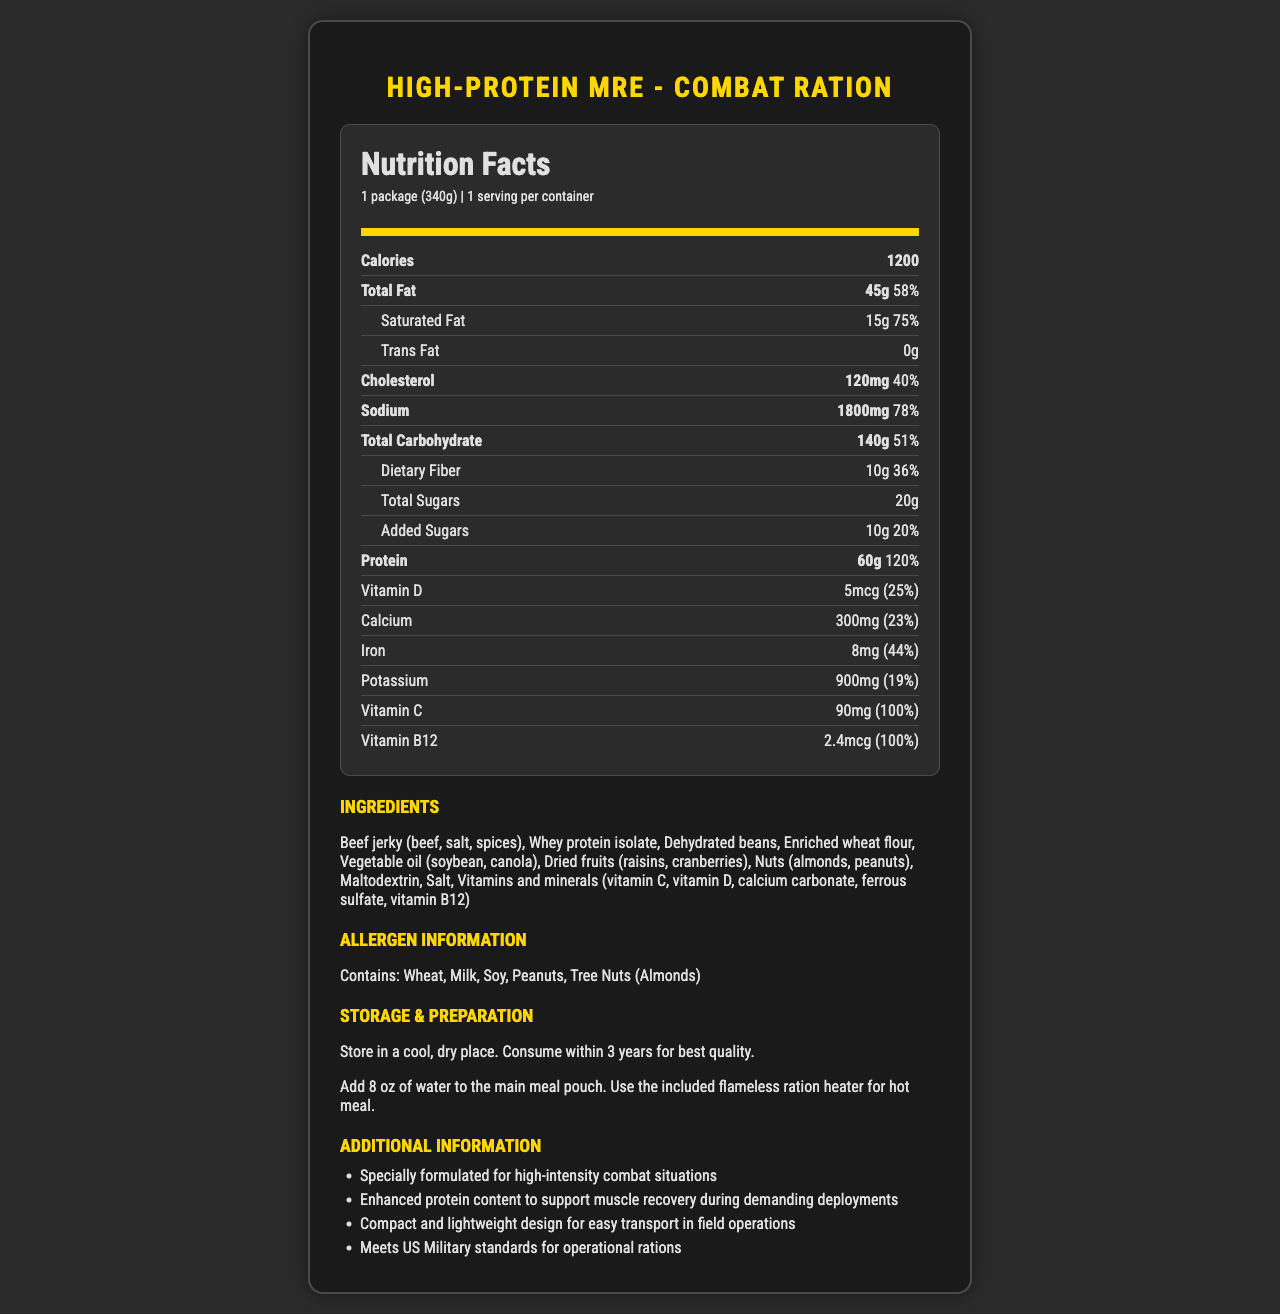what is the total fat content in the High-Protein MRE - Combat Ration? The nutrition label specifies that the total fat content is 45 grams.
Answer: 45g how much protein is in one serving of the High-Protein MRE - Combat Ration? The label clearly shows that each serving contains 60 grams of protein.
Answer: 60g what percentage of the daily value of sodium does one serving provide? The label indicates that one serving provides 78% of the daily value for sodium.
Answer: 78% how much added sugar does the High-Protein MRE - Combat Ration contain? The nutrition label states there are 10 grams of added sugars.
Answer: 10g which vitamins provide 100% daily value in this MRE? The nutrition label specifies that Vitamin C (90mg) and Vitamin B12 (2.4mcg) both provide 100% daily value.
Answer: Vitamin C and Vitamin B12 is there any trans fat in the High-Protein MRE - Combat Ration? The label clearly states that there is 0 grams of trans fat.
Answer: No A high level of protein is crucial for muscle recovery, especially during intense physical activities. How much protein does this MRE provide compared to the daily value percentage? A. 50% B. 90% C. 120% D. 150% The label indicates that the MRE provides 60 grams of protein, which is 120% of the daily value.
Answer: C What is the first ingredient listed for the High-Protein MRE - Combat Ration? A. Dehydrated beans B. Enriched wheat flour C. Beef jerky D. Whey protein isolate The first ingredient listed is beef jerky (beef, salt, spices).
Answer: C Does the product contain allergens such as wheat, milk, or soy? The allergen information section indicates it contains wheat, milk, and soy among other allergens.
Answer: Yes summarize the main idea of the document. The nutrition facts label highlights key nutrients, preparation steps, and additional information to ensure effective use in demanding military deployments.
Answer: The document provides detailed nutrition facts and ingredient information for the High-Protein MRE - Combat Ration, emphasizing its suitability for high-intensity combat situations with its enhanced protein content, storage and preparation instructions, and allergen details. What is the manufacturing date of the High-Protein MRE - Combat Ration? The document does not provide any details about the manufacturing date.
Answer: Not enough information 